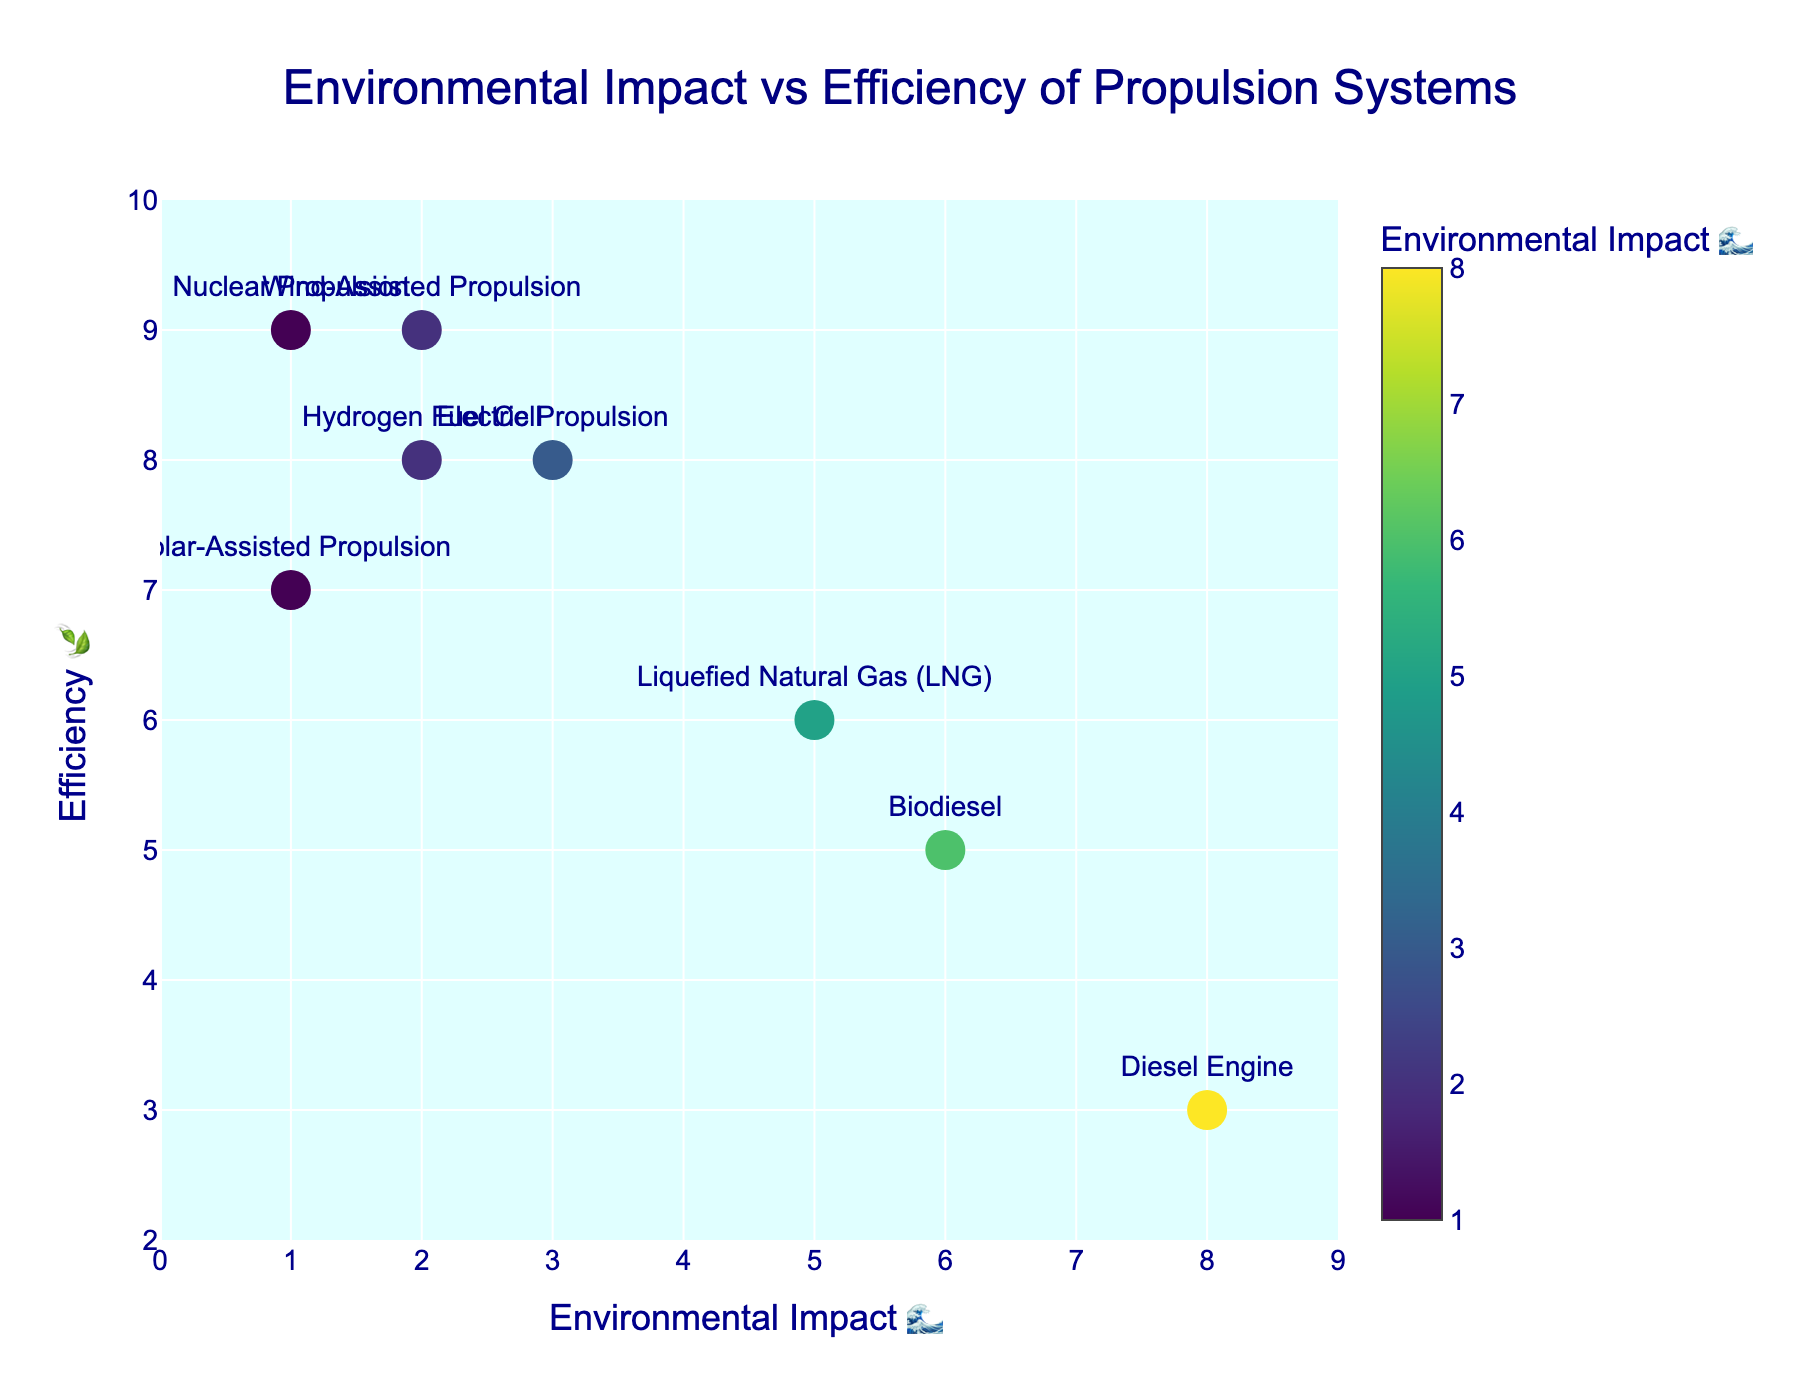What is the title of the chart? The title is displayed at the top of the chart.
Answer: "Environmental Impact vs Efficiency of Propulsion Systems" Which propulsion system has the lowest environmental impact (🌊)? By looking at the x-axis where the environmental impact is labeled, the lowest value (1) corresponds to Nuclear Propulsion and Solar-Assisted Propulsion.
Answer: Nuclear Propulsion, Solar-Assisted Propulsion What is the range of efficiency (🍃) values shown on the y-axis? The y-axis spans from a minimum of 2 to a maximum of 10, as evident from the axis labels and ticks.
Answer: 2 to 10 Which propulsion system has the highest efficiency (🍃)? The y-axis marks the highest efficiency at 9, and both Wind-Assisted Propulsion and Nuclear Propulsion are at this level.
Answer: Wind-Assisted Propulsion, Nuclear Propulsion Compare the environmental impact and efficiency between Diesel Engine and Biodiesel. Diesel Engine has an environmental impact of 8 and efficiency of 3, while Biodiesel has an environmental impact of 6 and efficiency of 5, according to the respective x and y positions.
Answer: Diesel Engine: 8🌊, 3🍃; Biodiesel: 6🌊, 5🍃 Which propulsion system balances low environmental impact (≤3🌊) with high efficiency (≥8🍃)? Identifying propulsion systems with environmental impact ≤3 and efficiency ≥8, those are Electric Propulsion, Wind-Assisted Propulsion, Nuclear Propulsion, and Hydrogen Fuel Cell.
Answer: Electric Propulsion, Wind-Assisted Propulsion, Nuclear Propulsion, Hydrogen Fuel Cell How many propulsion systems have an environmental impact greater than 5? Count the data points on the chart with an environmental impact above 5 on the x-axis, there are three such systems: Diesel Engine, Biodiesel, and LNG.
Answer: 3 Which system has a higher efficiency (🍃), Electric Propulsion or Hydrogen Fuel Cell, and by how much? Electric Propulsion and Hydrogen Fuel Cell both have an efficiency value of 8, according to the y-axis positions. The difference is 0.
Answer: Tie by 0 What is the average environmental impact (🌊) of Wind-Assisted Propulsion, Solar-Assisted Propulsion, and Nuclear Propulsion? Sum the environmental impacts of the three propulsion systems (2 + 1 + 1 = 4) and then divide by 3 to get the average.
Answer: (2 + 1 + 1) / 3 = 4 / 3 ≈ 1.33 What are the coordinates of the Liquefied Natural Gas (LNG) propulsion system on the chart? Locate the LNG system text label. It has an environmental impact of 5 (x-axis) and an efficiency of 6 (y-axis).
Answer: (5, 6) 